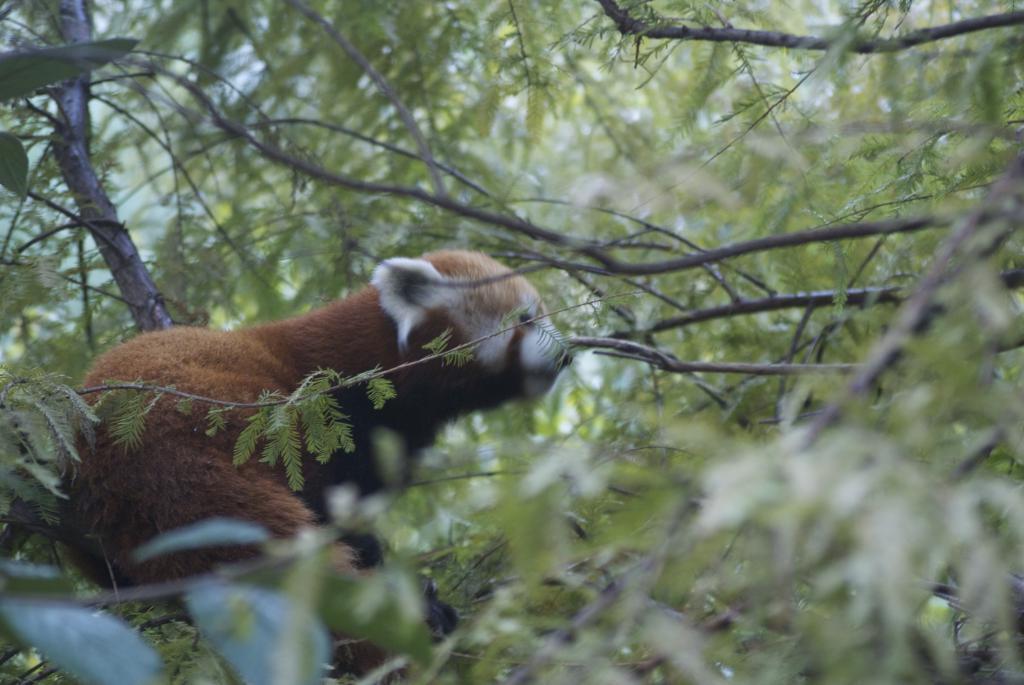How would you summarize this image in a sentence or two? In the picture we can see many plants and trees on it, we can see an animal sitting which is brown in color with white ears and nose. 